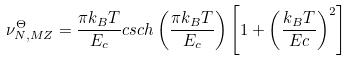<formula> <loc_0><loc_0><loc_500><loc_500>\nu _ { N , M Z } ^ { \Theta } = \frac { \pi k _ { B } T } { E _ { c } } c s c h \left ( \frac { \pi k _ { B } T } { E _ { c } } \right ) \left [ 1 + \left ( \frac { k _ { B } T } { E c } \right ) ^ { 2 } \right ]</formula> 